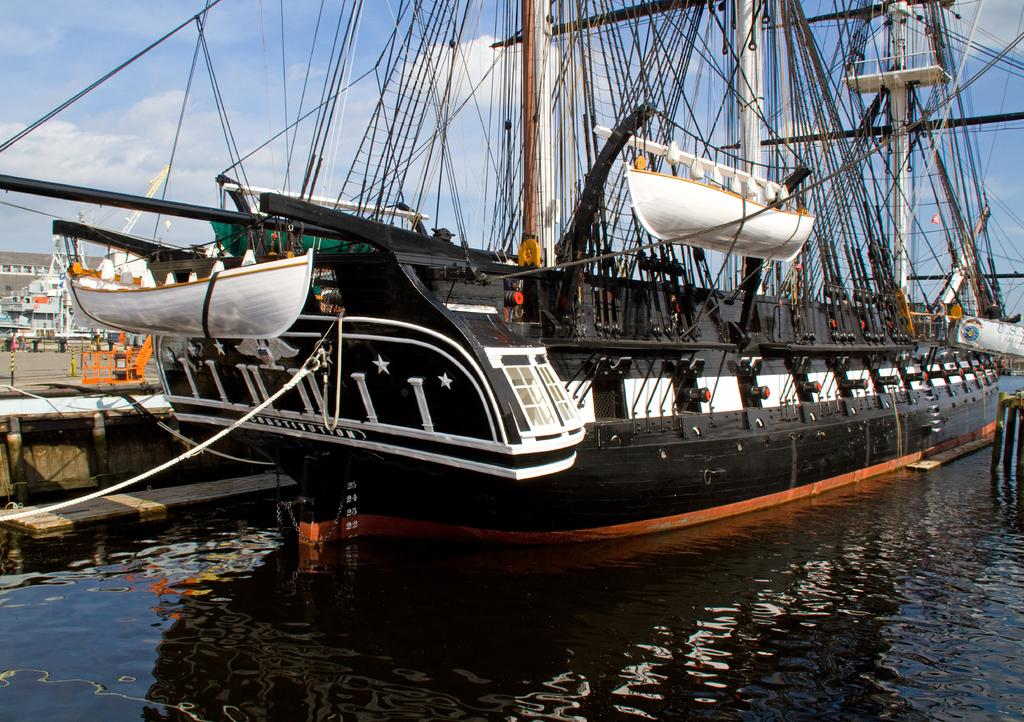What is the main subject of the image? The main subject of the image is a ship. Where is the ship located in the image? The ship is on the water surface in the image. What can be seen on the ship? There are ropes and other equipment on the ship. What is visible behind the ship? There is a boat behind the ship in the image. What can be seen in the background of the image? There are buildings in the background of the image. What type of plastic material can be seen floating near the ship in the image? There is no plastic material visible near the ship in the image. 